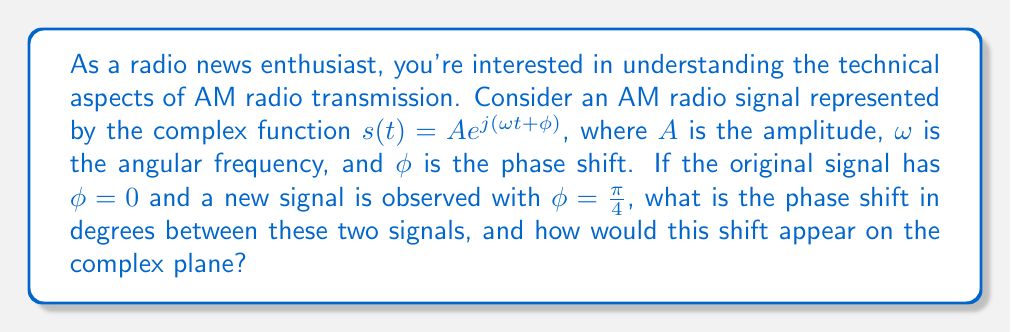Can you solve this math problem? To solve this problem, let's break it down into steps:

1) The phase shift is the difference between the two phase angles:
   $\Delta \phi = \phi_{new} - \phi_{original} = \frac{\pi}{4} - 0 = \frac{\pi}{4}$ radians

2) To convert radians to degrees, we use the formula:
   $\text{degrees} = \text{radians} \times \frac{180°}{\pi}$

   $\Delta \phi_{degrees} = \frac{\pi}{4} \times \frac{180°}{\pi} = 45°$

3) On the complex plane, a phase shift appears as a rotation of the signal vector. 

   [asy]
   import graph;
   size(200);
   
   draw((-1.5,0)--(1.5,0),Arrow);
   draw((0,-1.5)--(0,1.5),Arrow);
   
   draw((0,0)--(1,0),blue,Arrow);
   draw((0,0)--(cos(pi/4),sin(pi/4)),red,Arrow);
   
   label("Re", (1.5,0), E);
   label("Im", (0,1.5), N);
   label("Original", (1,0), SE, blue);
   label("New", (cos(pi/4),sin(pi/4)), NE, red);
   
   draw(arc((0,0), 0.5, 0, 45), green);
   label("45°", (0.4,0.2), green);
   [/asy]

   The blue arrow represents the original signal ($\phi = 0$), which aligns with the real axis.
   The red arrow represents the new signal ($\phi = \frac{\pi}{4}$), rotated 45° counterclockwise from the real axis.
   The green arc shows the phase shift between the two signals.

4) This phase shift would cause the AM radio signal to lead by 45°, which could affect the timing of the received audio information in the radio broadcast.
Answer: The phase shift between the two signals is 45°. On the complex plane, this appears as a 45° counterclockwise rotation of the signal vector from the real axis. 